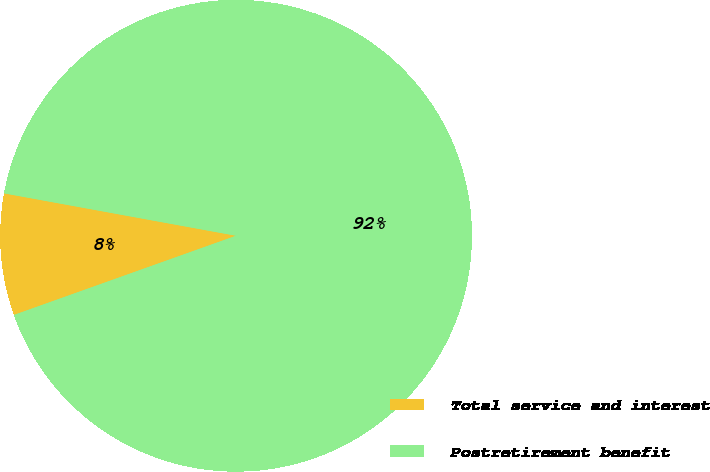Convert chart to OTSL. <chart><loc_0><loc_0><loc_500><loc_500><pie_chart><fcel>Total service and interest<fcel>Postretirement benefit<nl><fcel>8.33%<fcel>91.67%<nl></chart> 